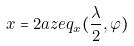<formula> <loc_0><loc_0><loc_500><loc_500>x = 2 a z e q _ { x } ( \frac { \lambda } { 2 } , \varphi )</formula> 